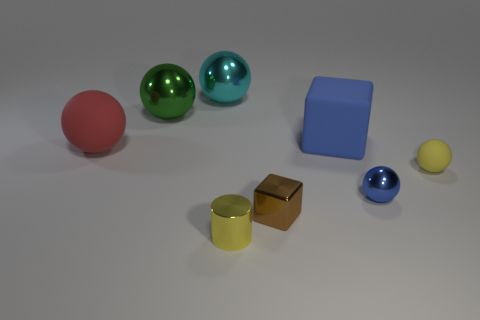Subtract all red balls. How many balls are left? 4 Subtract all blue spheres. How many spheres are left? 4 Subtract all brown balls. Subtract all blue cylinders. How many balls are left? 5 Add 2 blue rubber blocks. How many objects exist? 10 Subtract all cylinders. How many objects are left? 7 Add 8 blue rubber cubes. How many blue rubber cubes are left? 9 Add 7 small yellow things. How many small yellow things exist? 9 Subtract 0 red cubes. How many objects are left? 8 Subtract all tiny brown blocks. Subtract all metallic balls. How many objects are left? 4 